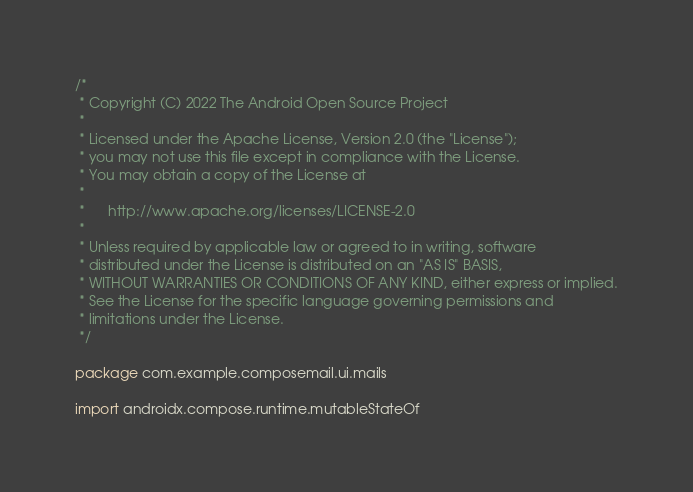<code> <loc_0><loc_0><loc_500><loc_500><_Kotlin_>/*
 * Copyright (C) 2022 The Android Open Source Project
 *
 * Licensed under the Apache License, Version 2.0 (the "License");
 * you may not use this file except in compliance with the License.
 * You may obtain a copy of the License at
 *
 *      http://www.apache.org/licenses/LICENSE-2.0
 *
 * Unless required by applicable law or agreed to in writing, software
 * distributed under the License is distributed on an "AS IS" BASIS,
 * WITHOUT WARRANTIES OR CONDITIONS OF ANY KIND, either express or implied.
 * See the License for the specific language governing permissions and
 * limitations under the License.
 */

package com.example.composemail.ui.mails

import androidx.compose.runtime.mutableStateOf
</code> 